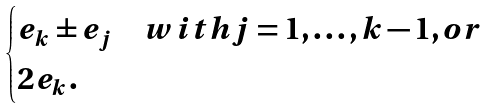Convert formula to latex. <formula><loc_0><loc_0><loc_500><loc_500>\begin{cases} e _ { k } \pm e _ { j } & w i t h j = 1 , \dots , k - 1 , o r \\ 2 e _ { k } . \end{cases}</formula> 